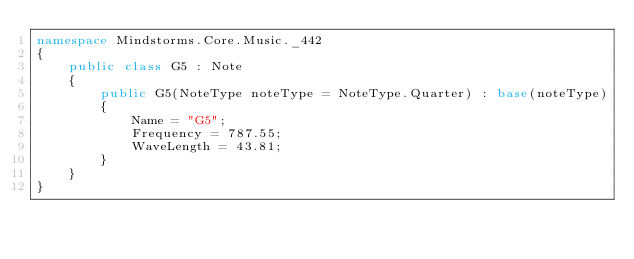Convert code to text. <code><loc_0><loc_0><loc_500><loc_500><_C#_>namespace Mindstorms.Core.Music._442
{
    public class G5 : Note
    {
        public G5(NoteType noteType = NoteType.Quarter) : base(noteType)
        {
            Name = "G5";
            Frequency = 787.55;
            WaveLength = 43.81;
        }
    }
}
</code> 